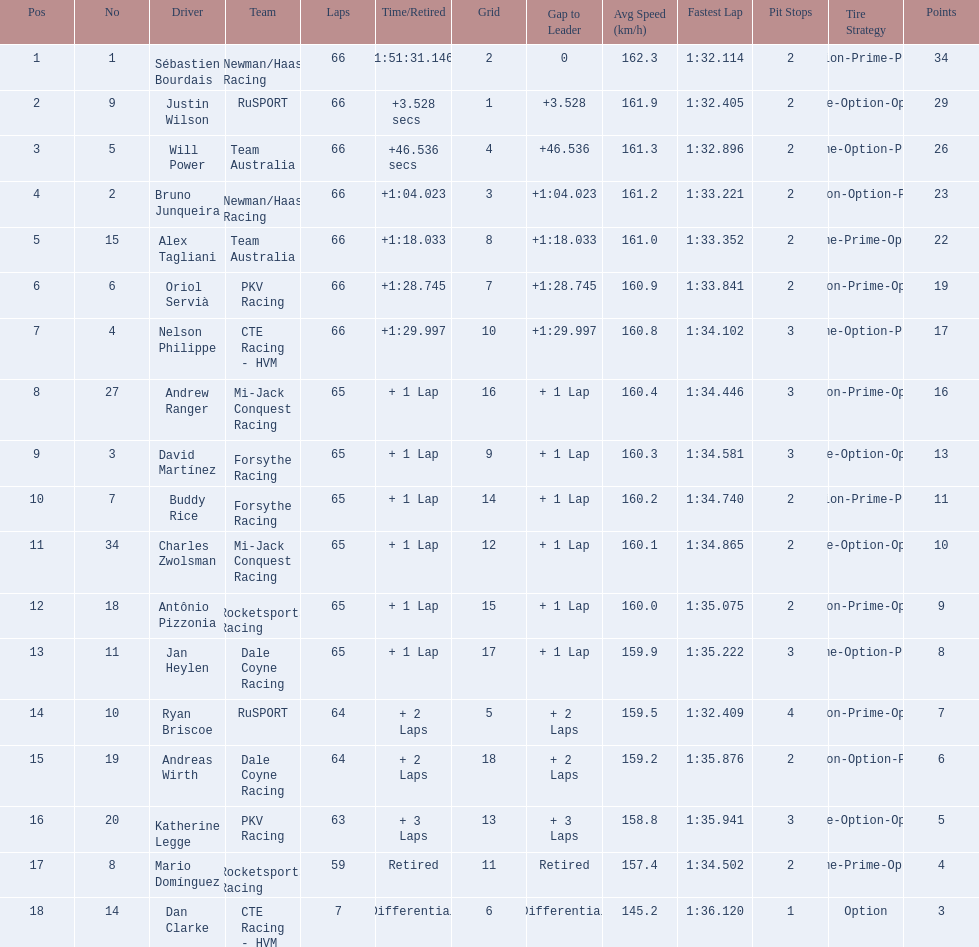Who are all the drivers? Sébastien Bourdais, Justin Wilson, Will Power, Bruno Junqueira, Alex Tagliani, Oriol Servià, Nelson Philippe, Andrew Ranger, David Martínez, Buddy Rice, Charles Zwolsman, Antônio Pizzonia, Jan Heylen, Ryan Briscoe, Andreas Wirth, Katherine Legge, Mario Domínguez, Dan Clarke. What position did they reach? 1, 2, 3, 4, 5, 6, 7, 8, 9, 10, 11, 12, 13, 14, 15, 16, 17, 18. What is the number for each driver? 1, 9, 5, 2, 15, 6, 4, 27, 3, 7, 34, 18, 11, 10, 19, 20, 8, 14. And which player's number and position match? Sébastien Bourdais. 